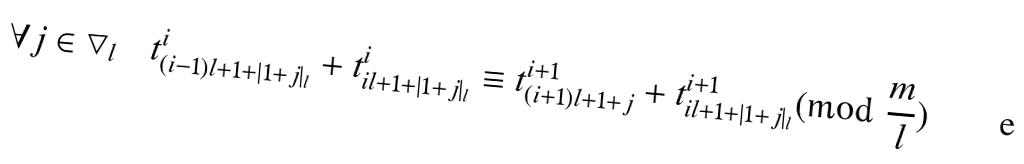Convert formula to latex. <formula><loc_0><loc_0><loc_500><loc_500>\forall j \in \bigtriangledown _ { l } \quad t ^ { i } _ { ( i - 1 ) l + 1 + | 1 + j | _ { l } } + t ^ { i } _ { i l + 1 + | 1 + j | _ { l } } \equiv t ^ { i + 1 } _ { ( i + 1 ) l + 1 + j } + t ^ { i + 1 } _ { i l + 1 + | 1 + j | _ { l } } ( \text {mod} \ \frac { m } { l } )</formula> 